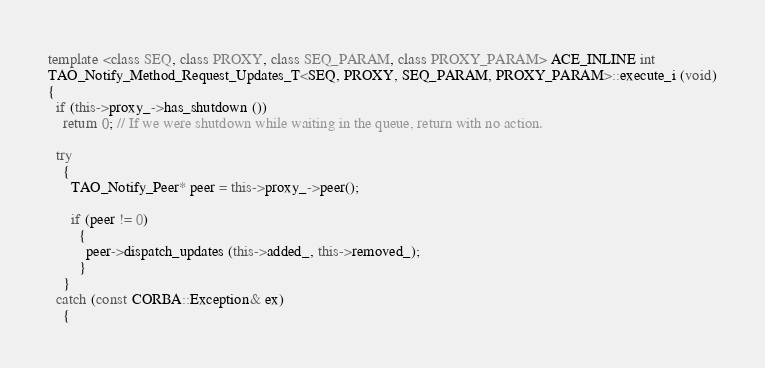Convert code to text. <code><loc_0><loc_0><loc_500><loc_500><_C++_>template <class SEQ, class PROXY, class SEQ_PARAM, class PROXY_PARAM> ACE_INLINE int
TAO_Notify_Method_Request_Updates_T<SEQ, PROXY, SEQ_PARAM, PROXY_PARAM>::execute_i (void)
{
  if (this->proxy_->has_shutdown ())
    return 0; // If we were shutdown while waiting in the queue, return with no action.

  try
    {
      TAO_Notify_Peer* peer = this->proxy_->peer();

      if (peer != 0)
        {
          peer->dispatch_updates (this->added_, this->removed_);
        }
    }
  catch (const CORBA::Exception& ex)
    {</code> 